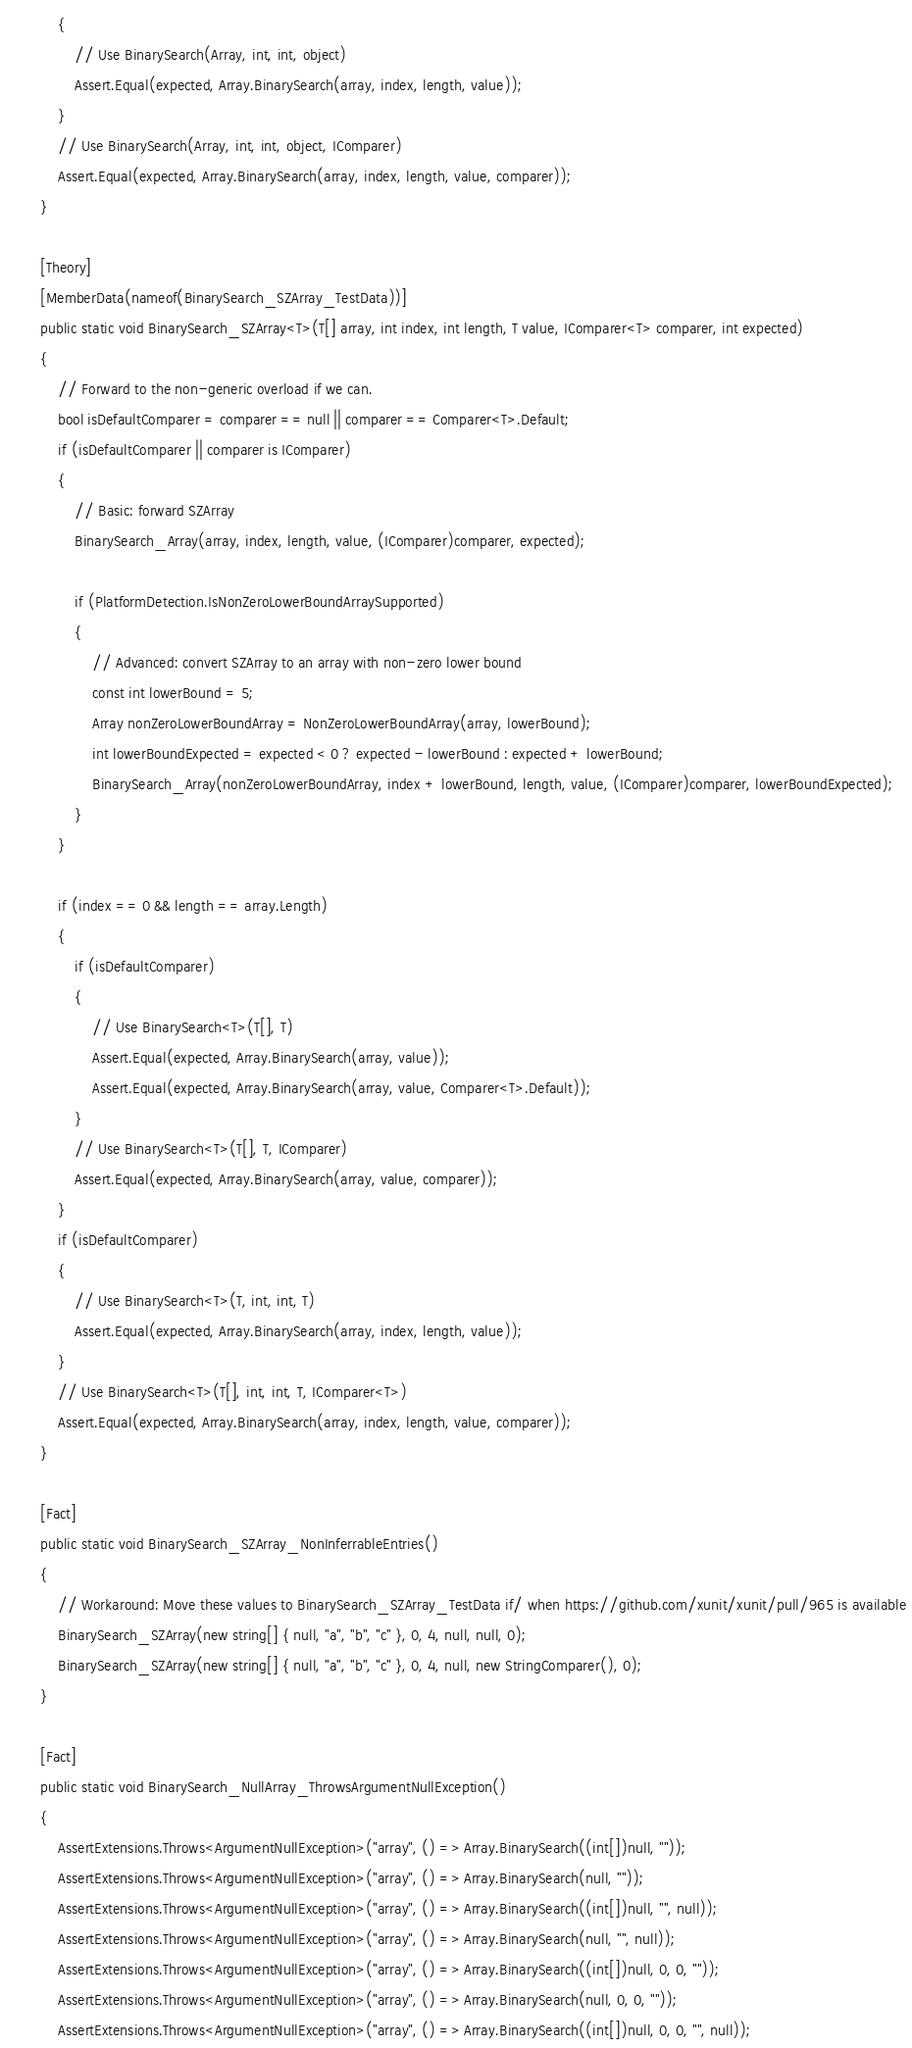<code> <loc_0><loc_0><loc_500><loc_500><_C#_>            {
                // Use BinarySearch(Array, int, int, object)
                Assert.Equal(expected, Array.BinarySearch(array, index, length, value));
            }
            // Use BinarySearch(Array, int, int, object, IComparer)
            Assert.Equal(expected, Array.BinarySearch(array, index, length, value, comparer));
        }

        [Theory]
        [MemberData(nameof(BinarySearch_SZArray_TestData))]
        public static void BinarySearch_SZArray<T>(T[] array, int index, int length, T value, IComparer<T> comparer, int expected)
        {
            // Forward to the non-generic overload if we can.
            bool isDefaultComparer = comparer == null || comparer == Comparer<T>.Default;
            if (isDefaultComparer || comparer is IComparer)
            {
                // Basic: forward SZArray
                BinarySearch_Array(array, index, length, value, (IComparer)comparer, expected);

                if (PlatformDetection.IsNonZeroLowerBoundArraySupported)
                {
                    // Advanced: convert SZArray to an array with non-zero lower bound
                    const int lowerBound = 5;
                    Array nonZeroLowerBoundArray = NonZeroLowerBoundArray(array, lowerBound);
                    int lowerBoundExpected = expected < 0 ? expected - lowerBound : expected + lowerBound;
                    BinarySearch_Array(nonZeroLowerBoundArray, index + lowerBound, length, value, (IComparer)comparer, lowerBoundExpected);
                }
            }
            
            if (index == 0 && length == array.Length)
            {
                if (isDefaultComparer)
                {
                    // Use BinarySearch<T>(T[], T)
                    Assert.Equal(expected, Array.BinarySearch(array, value));
                    Assert.Equal(expected, Array.BinarySearch(array, value, Comparer<T>.Default));
                }
                // Use BinarySearch<T>(T[], T, IComparer)
                Assert.Equal(expected, Array.BinarySearch(array, value, comparer));
            }
            if (isDefaultComparer)
            {
                // Use BinarySearch<T>(T, int, int, T)
                Assert.Equal(expected, Array.BinarySearch(array, index, length, value));
            }
            // Use BinarySearch<T>(T[], int, int, T, IComparer<T>)
            Assert.Equal(expected, Array.BinarySearch(array, index, length, value, comparer));
        }

        [Fact]
        public static void BinarySearch_SZArray_NonInferrableEntries()
        {
            // Workaround: Move these values to BinarySearch_SZArray_TestData if/ when https://github.com/xunit/xunit/pull/965 is available
            BinarySearch_SZArray(new string[] { null, "a", "b", "c" }, 0, 4, null, null, 0);
            BinarySearch_SZArray(new string[] { null, "a", "b", "c" }, 0, 4, null, new StringComparer(), 0);
        }

        [Fact]
        public static void BinarySearch_NullArray_ThrowsArgumentNullException()
        {
            AssertExtensions.Throws<ArgumentNullException>("array", () => Array.BinarySearch((int[])null, ""));
            AssertExtensions.Throws<ArgumentNullException>("array", () => Array.BinarySearch(null, ""));
            AssertExtensions.Throws<ArgumentNullException>("array", () => Array.BinarySearch((int[])null, "", null));
            AssertExtensions.Throws<ArgumentNullException>("array", () => Array.BinarySearch(null, "", null));
            AssertExtensions.Throws<ArgumentNullException>("array", () => Array.BinarySearch((int[])null, 0, 0, ""));
            AssertExtensions.Throws<ArgumentNullException>("array", () => Array.BinarySearch(null, 0, 0, ""));
            AssertExtensions.Throws<ArgumentNullException>("array", () => Array.BinarySearch((int[])null, 0, 0, "", null));</code> 